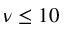Convert formula to latex. <formula><loc_0><loc_0><loc_500><loc_500>\nu \leq 1 0</formula> 